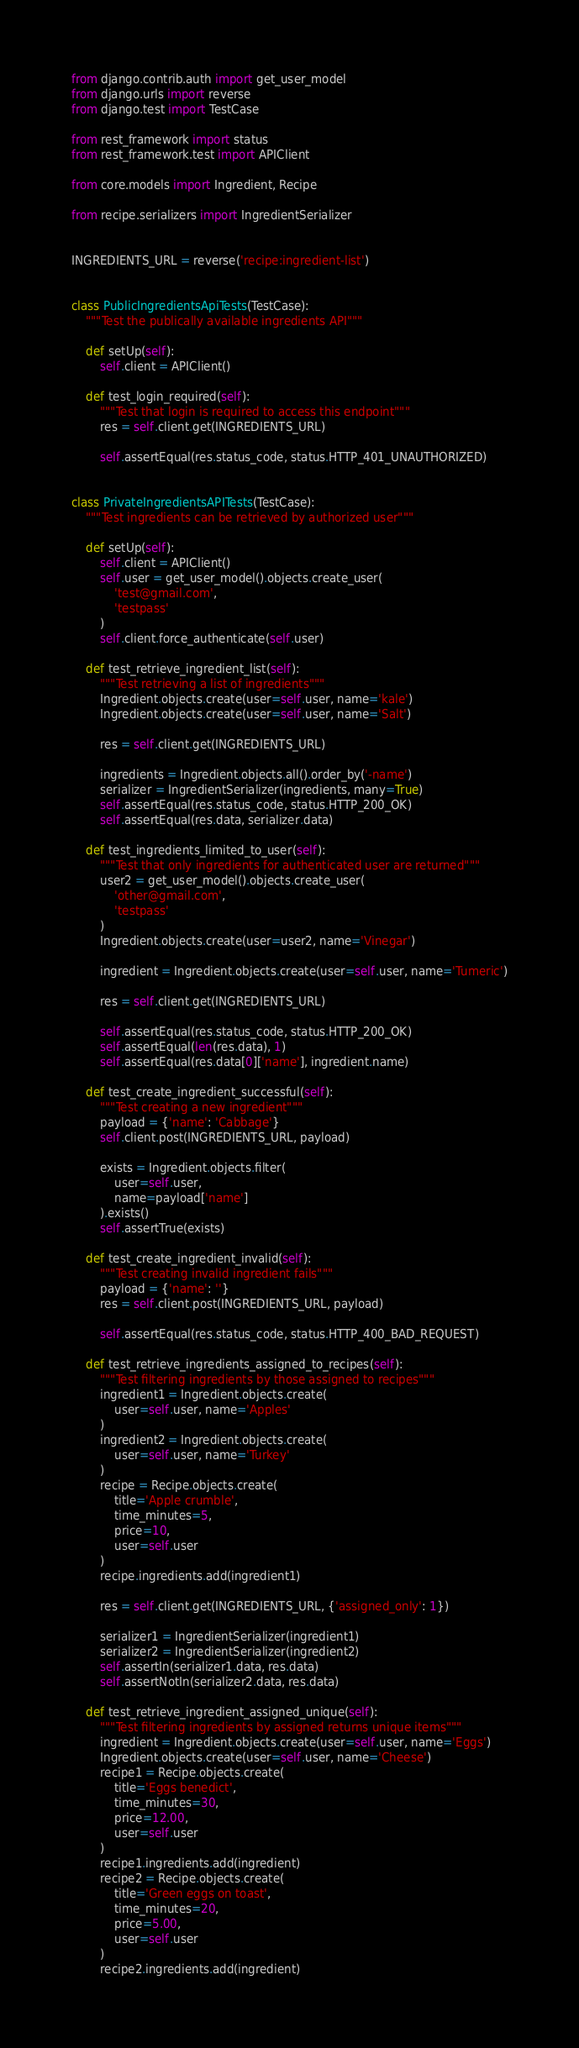Convert code to text. <code><loc_0><loc_0><loc_500><loc_500><_Python_>from django.contrib.auth import get_user_model
from django.urls import reverse
from django.test import TestCase

from rest_framework import status
from rest_framework.test import APIClient

from core.models import Ingredient, Recipe

from recipe.serializers import IngredientSerializer


INGREDIENTS_URL = reverse('recipe:ingredient-list')


class PublicIngredientsApiTests(TestCase):
    """Test the publically available ingredients API"""

    def setUp(self):
        self.client = APIClient()

    def test_login_required(self):
        """Test that login is required to access this endpoint"""
        res = self.client.get(INGREDIENTS_URL)

        self.assertEqual(res.status_code, status.HTTP_401_UNAUTHORIZED)


class PrivateIngredientsAPITests(TestCase):
    """Test ingredients can be retrieved by authorized user"""

    def setUp(self):
        self.client = APIClient()
        self.user = get_user_model().objects.create_user(
            'test@gmail.com',
            'testpass'
        )
        self.client.force_authenticate(self.user)

    def test_retrieve_ingredient_list(self):
        """Test retrieving a list of ingredients"""
        Ingredient.objects.create(user=self.user, name='kale')
        Ingredient.objects.create(user=self.user, name='Salt')

        res = self.client.get(INGREDIENTS_URL)

        ingredients = Ingredient.objects.all().order_by('-name')
        serializer = IngredientSerializer(ingredients, many=True)
        self.assertEqual(res.status_code, status.HTTP_200_OK)
        self.assertEqual(res.data, serializer.data)

    def test_ingredients_limited_to_user(self):
        """Test that only ingredients for authenticated user are returned"""
        user2 = get_user_model().objects.create_user(
            'other@gmail.com',
            'testpass'
        )
        Ingredient.objects.create(user=user2, name='Vinegar')

        ingredient = Ingredient.objects.create(user=self.user, name='Tumeric')

        res = self.client.get(INGREDIENTS_URL)

        self.assertEqual(res.status_code, status.HTTP_200_OK)
        self.assertEqual(len(res.data), 1)
        self.assertEqual(res.data[0]['name'], ingredient.name)

    def test_create_ingredient_successful(self):
        """Test creating a new ingredient"""
        payload = {'name': 'Cabbage'}
        self.client.post(INGREDIENTS_URL, payload)

        exists = Ingredient.objects.filter(
            user=self.user,
            name=payload['name']
        ).exists()
        self.assertTrue(exists)

    def test_create_ingredient_invalid(self):
        """Test creating invalid ingredient fails"""
        payload = {'name': ''}
        res = self.client.post(INGREDIENTS_URL, payload)

        self.assertEqual(res.status_code, status.HTTP_400_BAD_REQUEST)

    def test_retrieve_ingredients_assigned_to_recipes(self):
        """Test filtering ingredients by those assigned to recipes"""
        ingredient1 = Ingredient.objects.create(
            user=self.user, name='Apples'
        )
        ingredient2 = Ingredient.objects.create(
            user=self.user, name='Turkey'
        )
        recipe = Recipe.objects.create(
            title='Apple crumble',
            time_minutes=5,
            price=10,
            user=self.user
        )
        recipe.ingredients.add(ingredient1)

        res = self.client.get(INGREDIENTS_URL, {'assigned_only': 1})

        serializer1 = IngredientSerializer(ingredient1)
        serializer2 = IngredientSerializer(ingredient2)
        self.assertIn(serializer1.data, res.data)
        self.assertNotIn(serializer2.data, res.data)

    def test_retrieve_ingredient_assigned_unique(self):
        """Test filtering ingredients by assigned returns unique items"""
        ingredient = Ingredient.objects.create(user=self.user, name='Eggs')
        Ingredient.objects.create(user=self.user, name='Cheese')
        recipe1 = Recipe.objects.create(
            title='Eggs benedict',
            time_minutes=30,
            price=12.00,
            user=self.user
        )
        recipe1.ingredients.add(ingredient)
        recipe2 = Recipe.objects.create(
            title='Green eggs on toast',
            time_minutes=20,
            price=5.00,
            user=self.user
        )
        recipe2.ingredients.add(ingredient)
</code> 